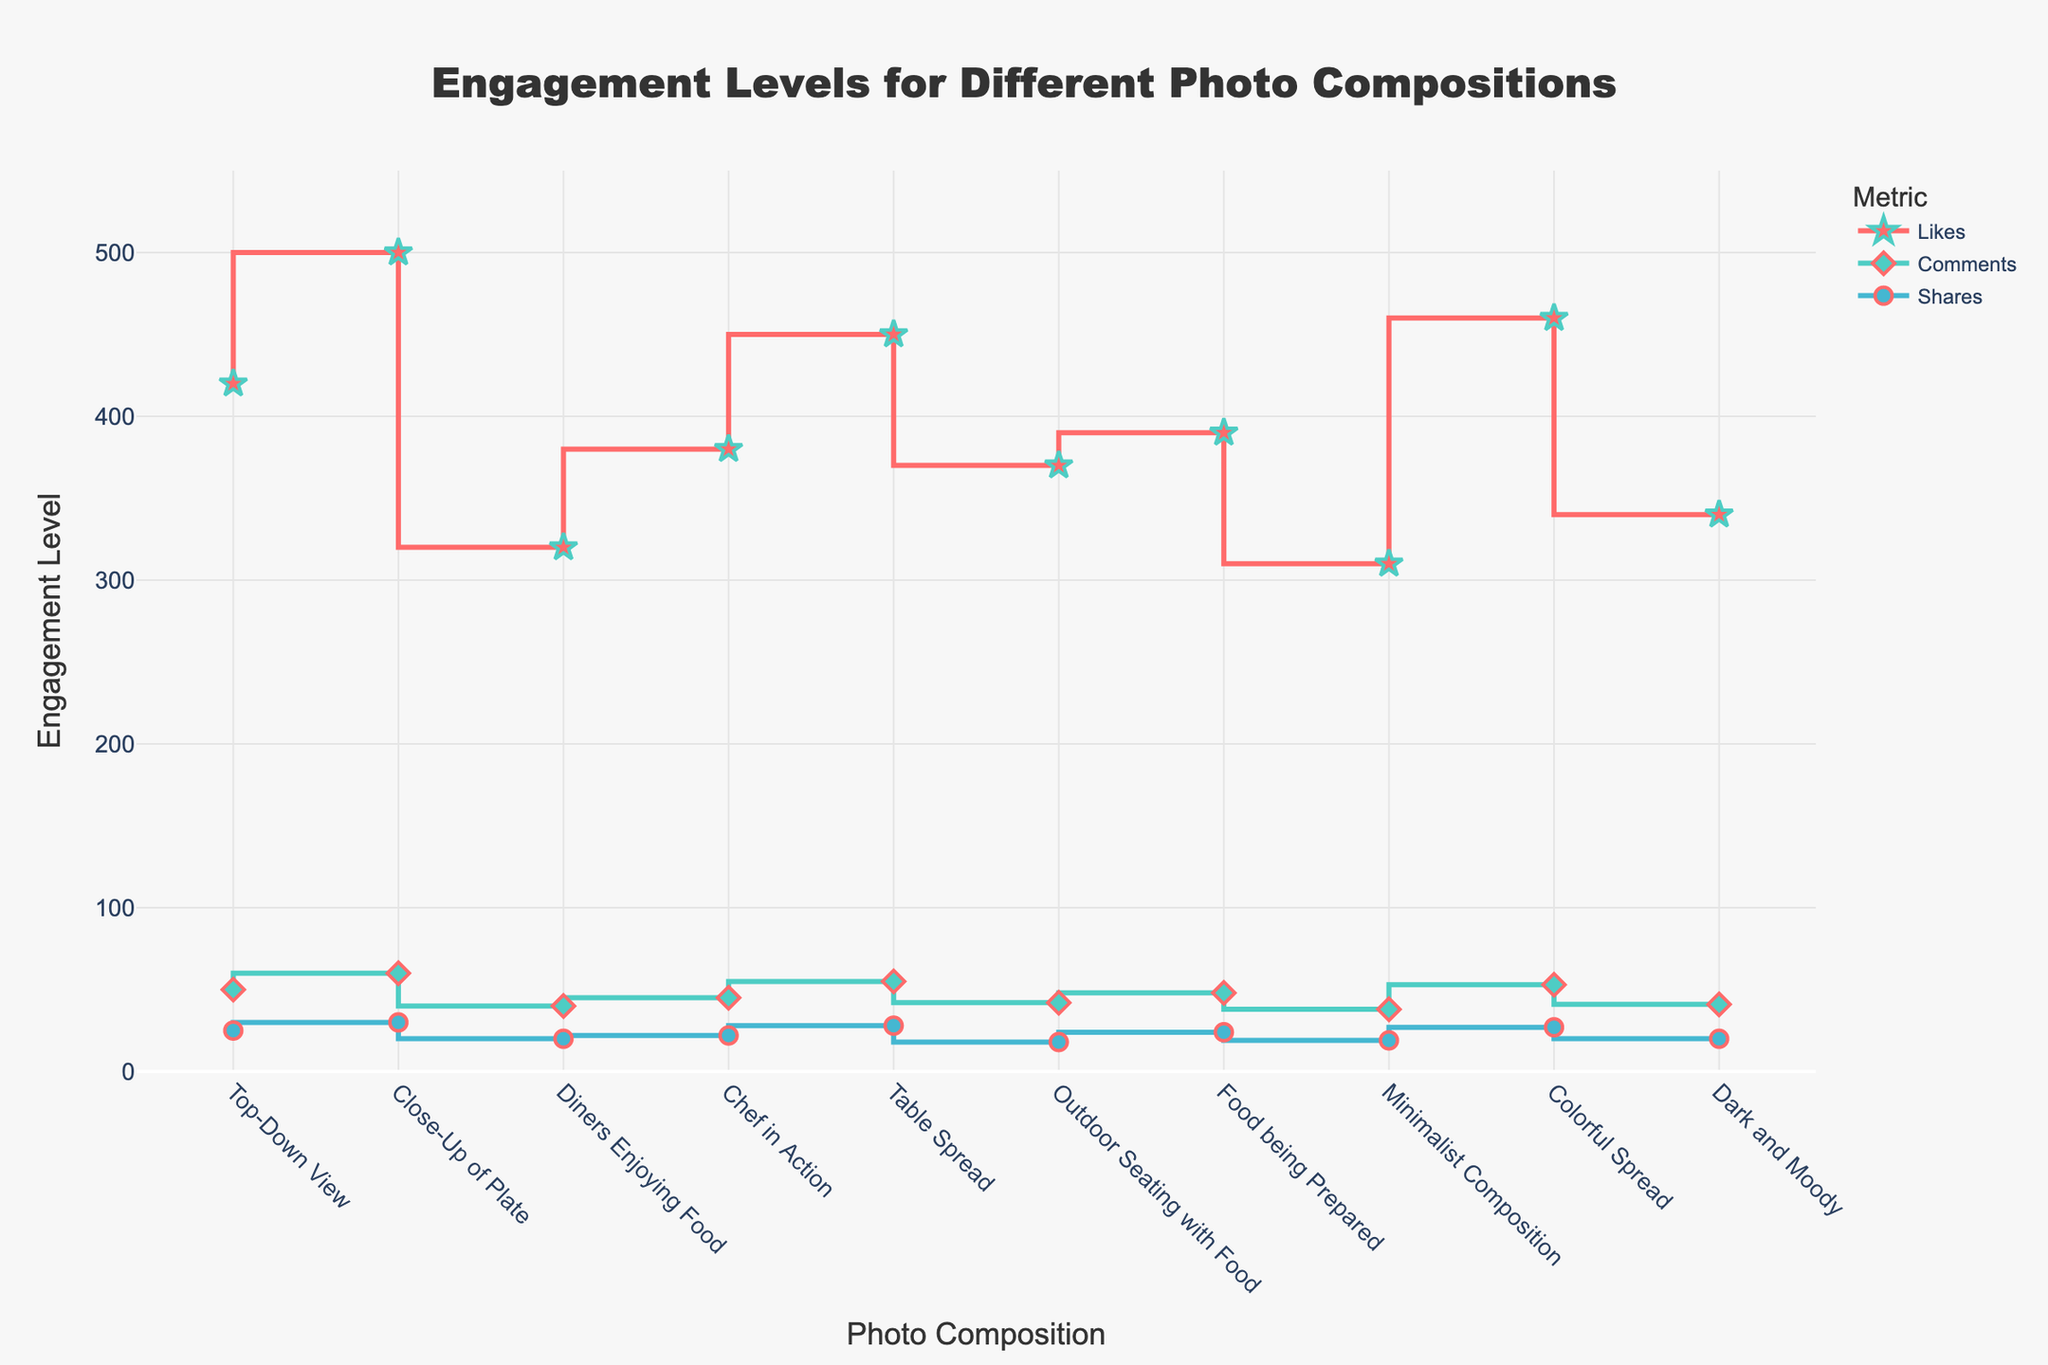What is the title of the figure? The title is clearly displayed at the top of the plot, which reads "Engagement Levels for Different Photo Compositions".
Answer: Engagement Levels for Different Photo Compositions What are the three engagement metrics shown in the figure? The three different colored lines in the plot represent Likes, Comments, and Shares as indicated in the legend.
Answer: Likes, Comments, Shares Which photo composition received the highest number of Likes? By observing the peak of the 'Likes' line, it is evident that "Close-Up of Plate" has the highest value.
Answer: Close-Up of Plate What is the range of Likes across all photo compositions? The smallest value for Likes is 310 (Minimalist Composition) and the highest is 500 (Close-Up of Plate). Therefore, the range is 500 - 310.
Answer: 190 Which photo composition has the lowest number of Comments? By identifying the lowest point on the 'Comments' line, we see "Minimalist Composition" has the fewest comments, with 38.
Answer: Minimalist Composition How many photo compositions have more than 50 Shares? Observing the 'Shares' line, none of the photo compositions have Shares exceeding 50.
Answer: 0 What is the second highest number of Likes recorded and which photo composition achieves it? By examining the 'Likes' values, the second highest is 460 (Colorful Spread), following the highest (500).
Answer: Colorful Spread How do the engagement levels (Likes, Comments, Shares) for 'Dark and Moody' composition compare to 'Colorful Spread' composition? For 'Dark and Moody': Likes (340), Comments (41), Shares (20); For 'Colorful Spread': Likes (460), Comments (53), Shares (27). Colorful Spread has higher values in all three metrics.
Answer: Colorful Spread has higher values in all metrics What is the average number of Comments across all photo compositions? Sum all the Comments (50 + 60 + 40 + 45 + 55 + 42 + 48 + 38 + 53 + 41 = 472) and divide by the number of compositions (10), giving 472 / 10.
Answer: 47.2 How does the engagement level for 'Table Spread' in terms of Shares compare to 'Chef in Action'? Referring to the plot, 'Table Spread' has 28 Shares, while 'Chef in Action' has 22 Shares. 'Table Spread' has 6 more Shares than 'Chef in Action'.
Answer: Table Spread has 6 more Shares 